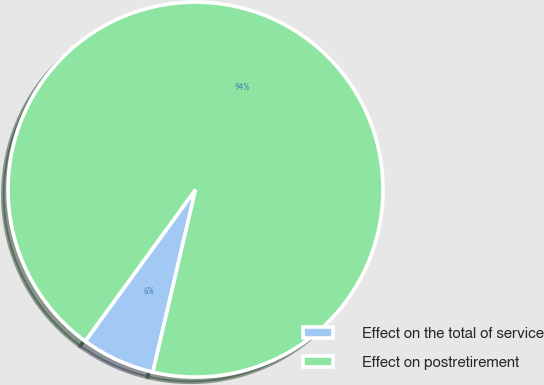Convert chart to OTSL. <chart><loc_0><loc_0><loc_500><loc_500><pie_chart><fcel>Effect on the total of service<fcel>Effect on postretirement<nl><fcel>6.36%<fcel>93.64%<nl></chart> 